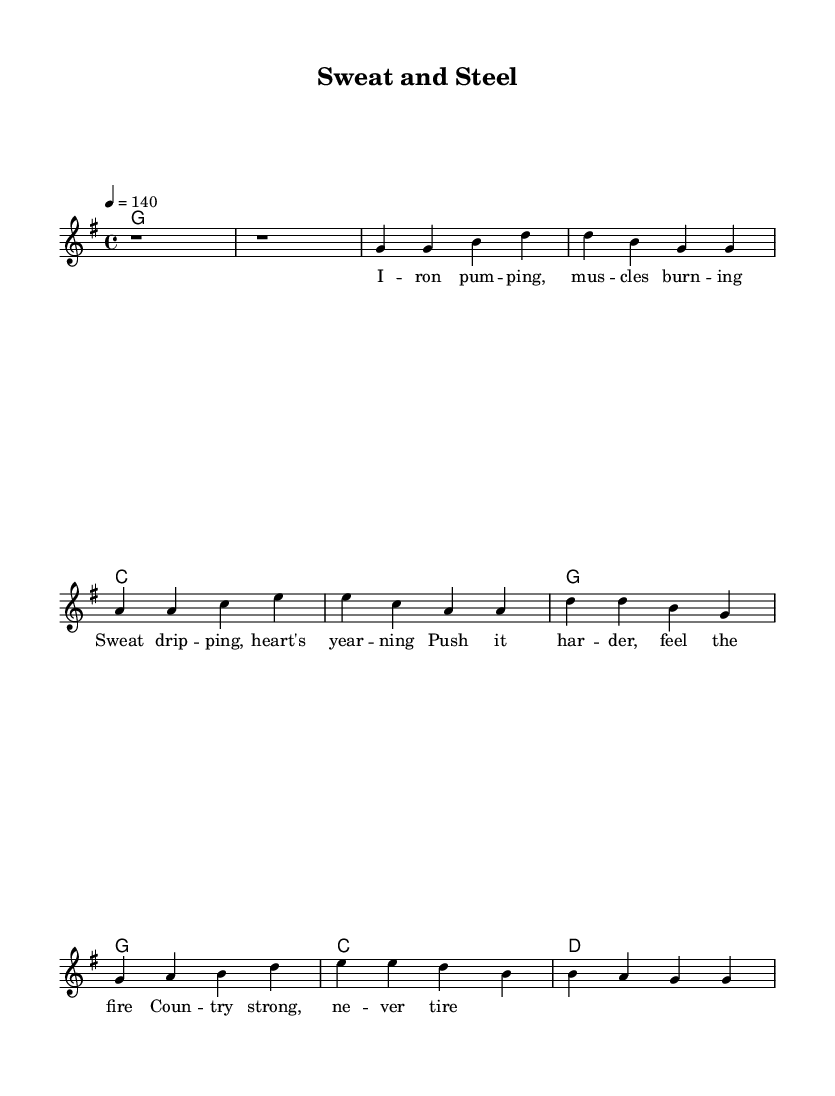What is the key signature of this music? The key signature is G major, which has one sharp (F#).
Answer: G major What is the time signature of this music? The time signature is 4/4, indicating four beats per measure.
Answer: 4/4 What is the tempo marking of this piece? The tempo marking is 140, which indicates how fast the piece should be played.
Answer: 140 How many measures are in the verse? The verse consists of four measures, as indicated by the notation under the verse section.
Answer: Four What is the main theme of the lyrics? The main theme emphasizes fitness and perseverance, focusing on pushing oneself harder in workouts.
Answer: Fitness and perseverance In which section do the words "Push it harder, feel the fire" appear? These words are in the chorus section, highlighted after the first verse.
Answer: Chorus What chord progression is used in the chorus? The chord progression in the chorus is G, G, C, D, indicating the harmonization for that section.
Answer: G, G, C, D 